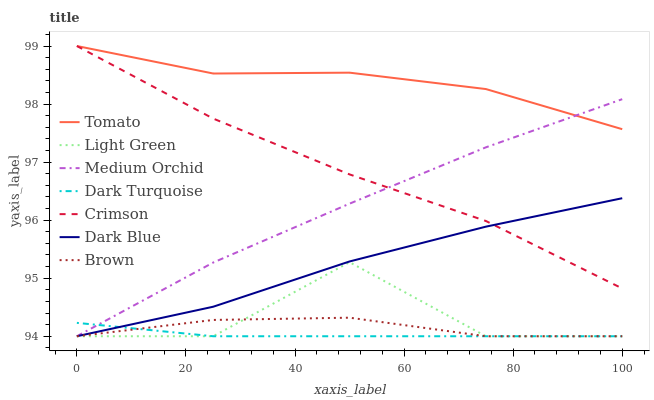Does Brown have the minimum area under the curve?
Answer yes or no. No. Does Brown have the maximum area under the curve?
Answer yes or no. No. Is Brown the smoothest?
Answer yes or no. No. Is Brown the roughest?
Answer yes or no. No. Does Crimson have the lowest value?
Answer yes or no. No. Does Brown have the highest value?
Answer yes or no. No. Is Dark Turquoise less than Crimson?
Answer yes or no. Yes. Is Tomato greater than Brown?
Answer yes or no. Yes. Does Dark Turquoise intersect Crimson?
Answer yes or no. No. 